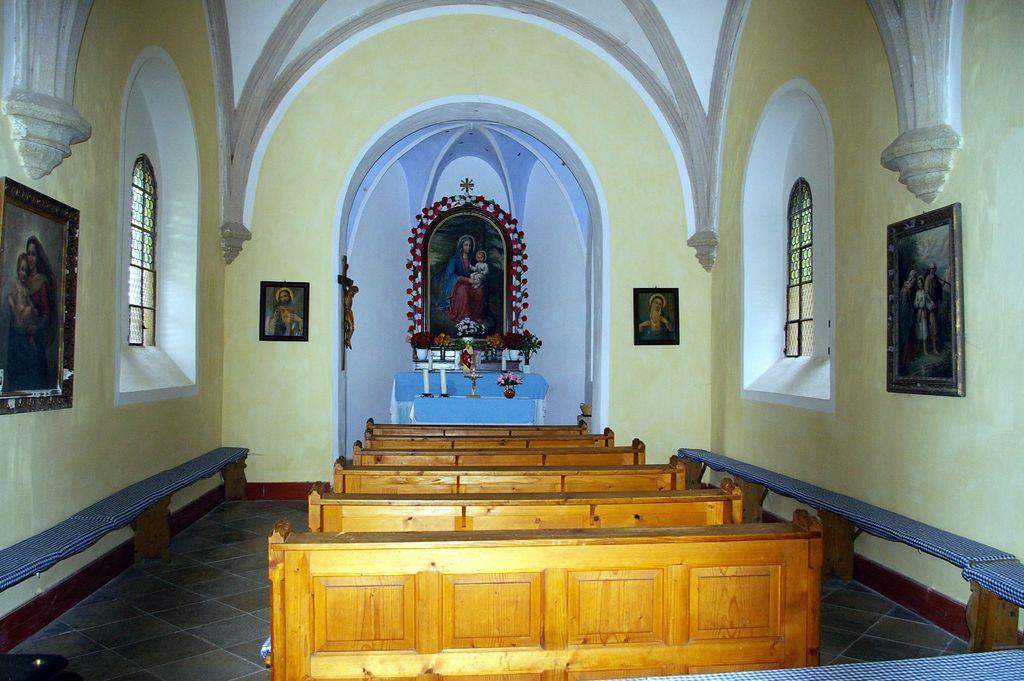What type of furniture is present in the image? There are tables and benches in the image. What can be seen on the wall in the image? There are photo frames on the wall. What architectural feature is visible in the image? There are windows in the image. What is visible in the background of the image? There are objects on the stairs in the background of the image. What type of rhythm can be heard coming from the lunch in the image? There is no lunch present in the image, and therefore no rhythm can be heard. What observation can be made about the photo frames on the wall? The question is not absurd, as it can be answered definitively based on the provided facts. The observation that can be made about the photo frames on the wall is that they are present in the image. 